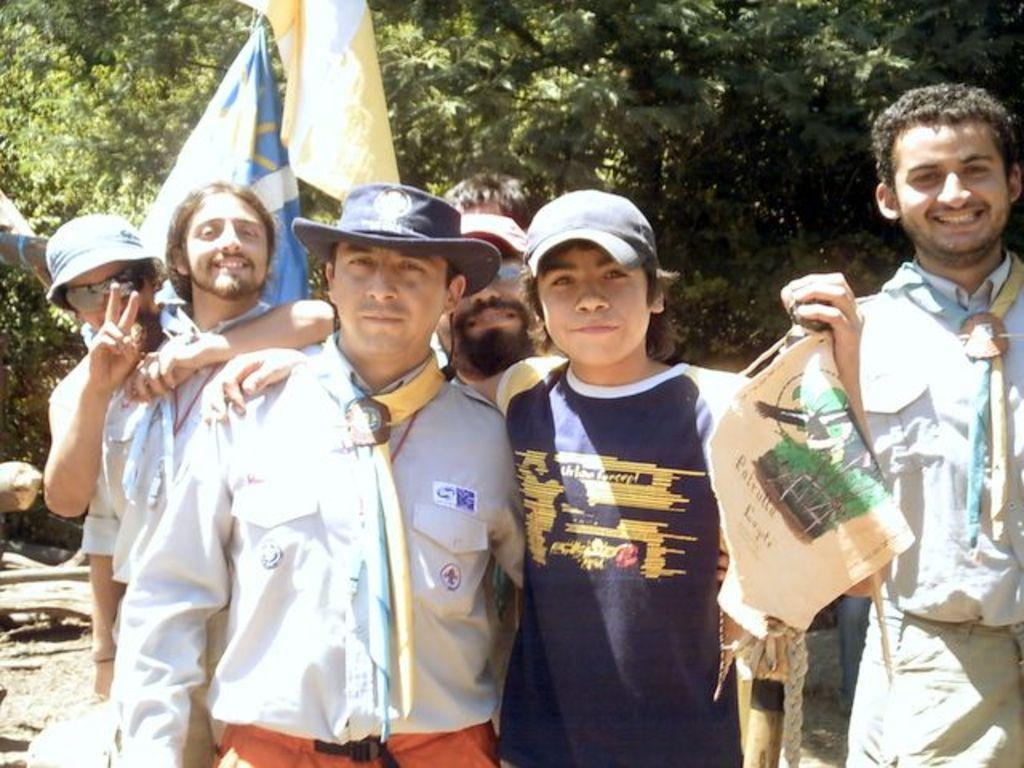Who is present in the image? There are people in the image. What are the people doing in the image? The people are smiling and posing for a picture. What can be seen in the background of the image? There are trees and flags in the background of the image. How many kittens are sitting on the rings in the image? There are no rings or kittens present in the image. What type of society is depicted in the image? The image does not depict a society; it features people posing for a picture with trees and flags in the background. 